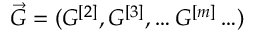Convert formula to latex. <formula><loc_0><loc_0><loc_500><loc_500>\vec { G } = ( G ^ { [ 2 ] } , G ^ { [ 3 ] } , \dots G ^ { [ m ] } \dots )</formula> 